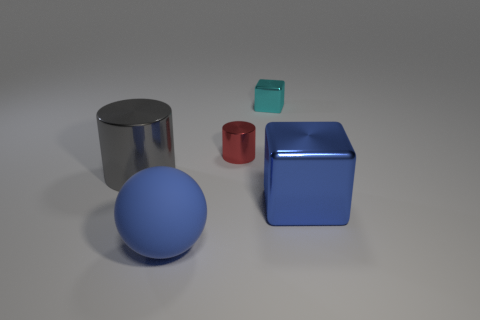How do the textures of the objects compare? The objects exhibit various textures: the sphere has a matte finish, the large cylinder and cube have reflective surfaces, and the smaller cube has a different, slightly opaque appearance. These differing textures create an interesting interplay of light, reflection, and shadow in the image. 